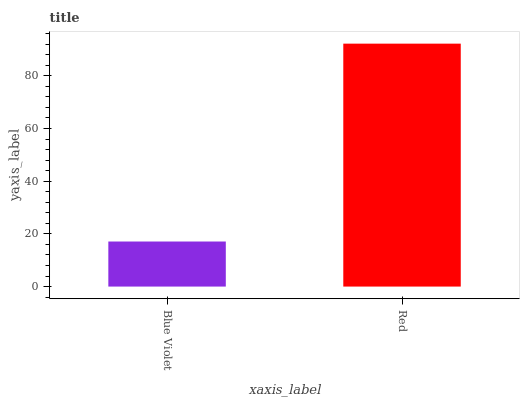Is Red the minimum?
Answer yes or no. No. Is Red greater than Blue Violet?
Answer yes or no. Yes. Is Blue Violet less than Red?
Answer yes or no. Yes. Is Blue Violet greater than Red?
Answer yes or no. No. Is Red less than Blue Violet?
Answer yes or no. No. Is Red the high median?
Answer yes or no. Yes. Is Blue Violet the low median?
Answer yes or no. Yes. Is Blue Violet the high median?
Answer yes or no. No. Is Red the low median?
Answer yes or no. No. 